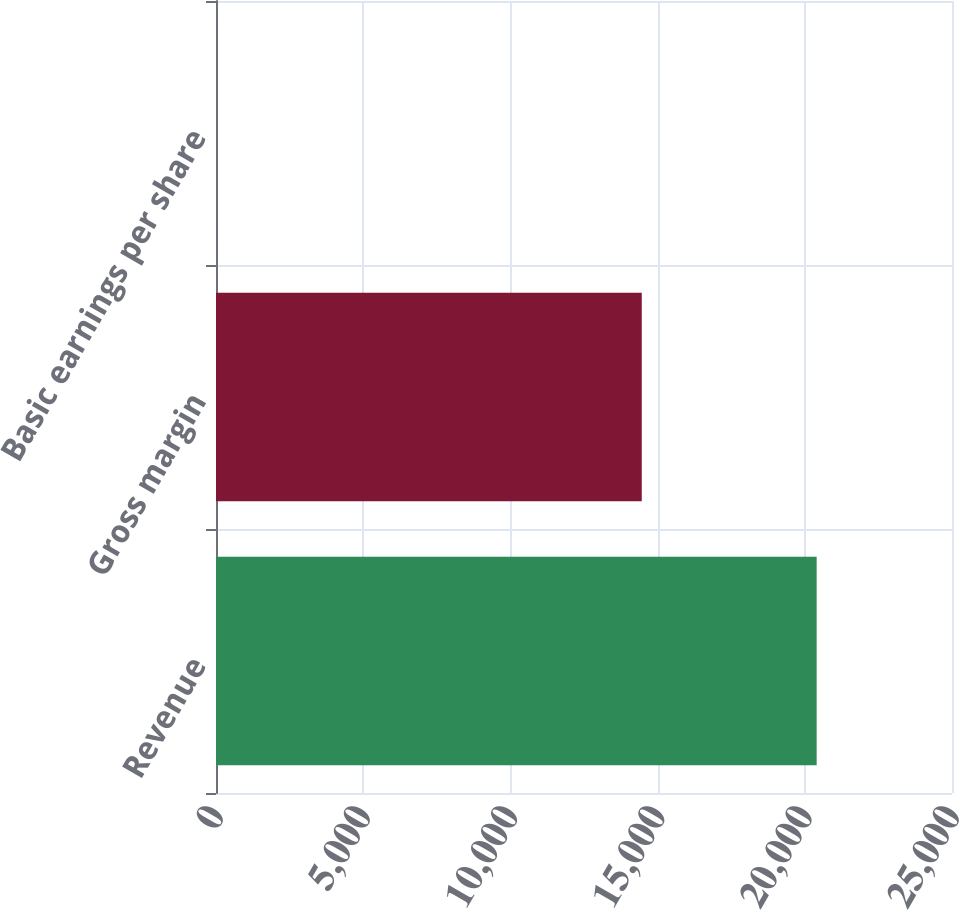Convert chart to OTSL. <chart><loc_0><loc_0><loc_500><loc_500><bar_chart><fcel>Revenue<fcel>Gross margin<fcel>Basic earnings per share<nl><fcel>20403<fcel>14462<fcel>0.68<nl></chart> 